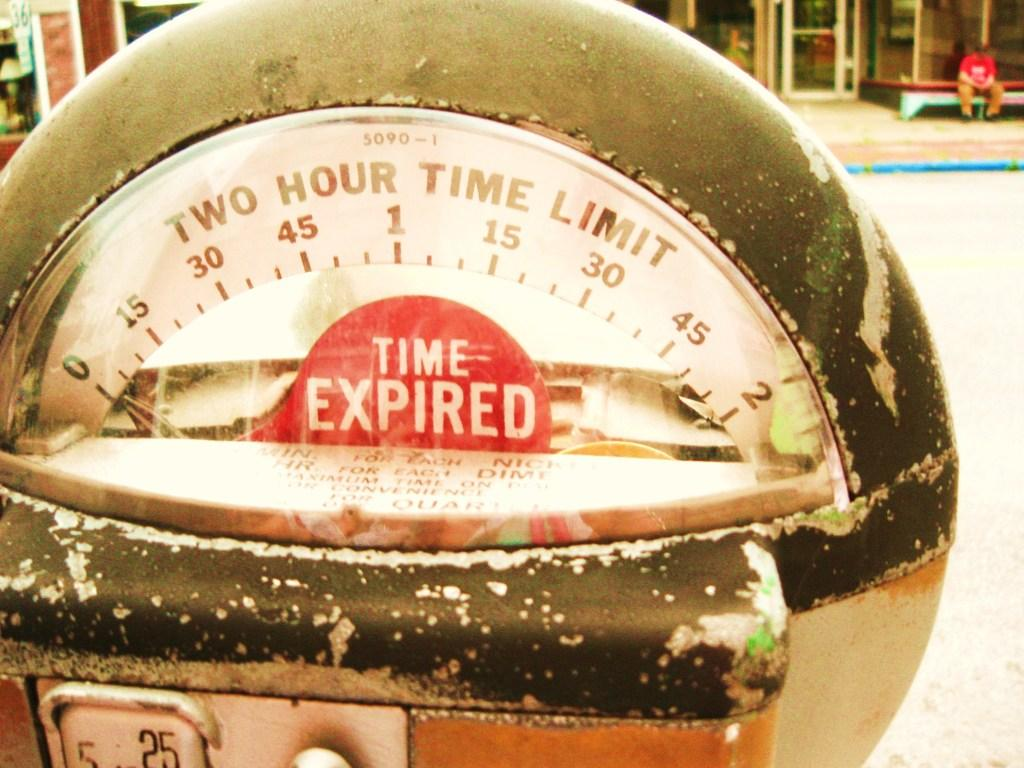<image>
Relay a brief, clear account of the picture shown. An older parking meter that has time expired. 